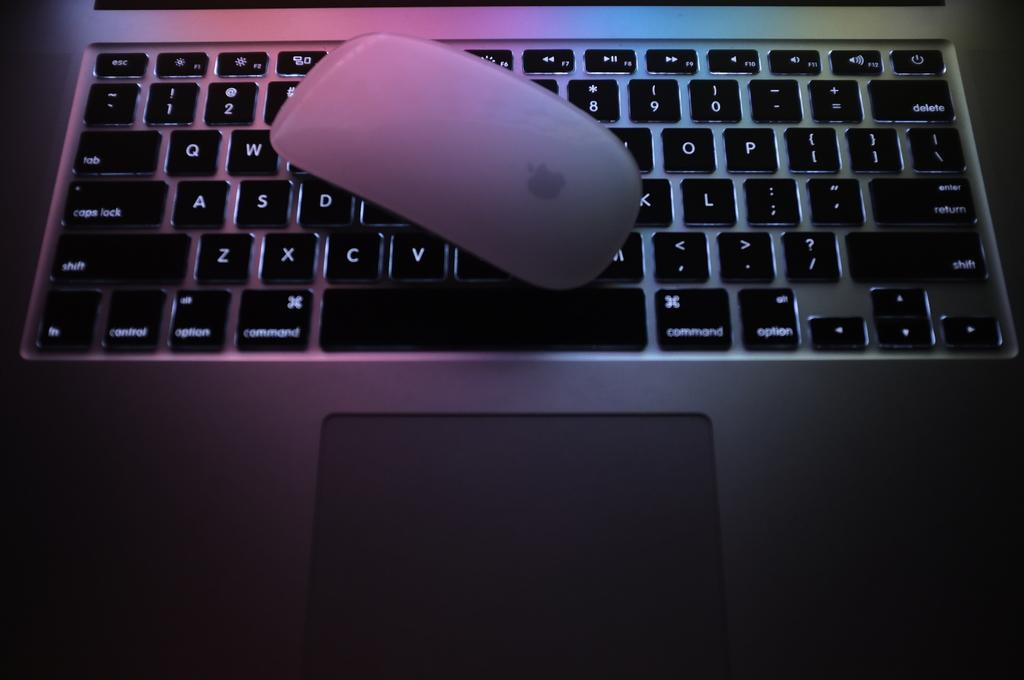<image>
Relay a brief, clear account of the picture shown. an apple mouse on top of a macbook keyboard 